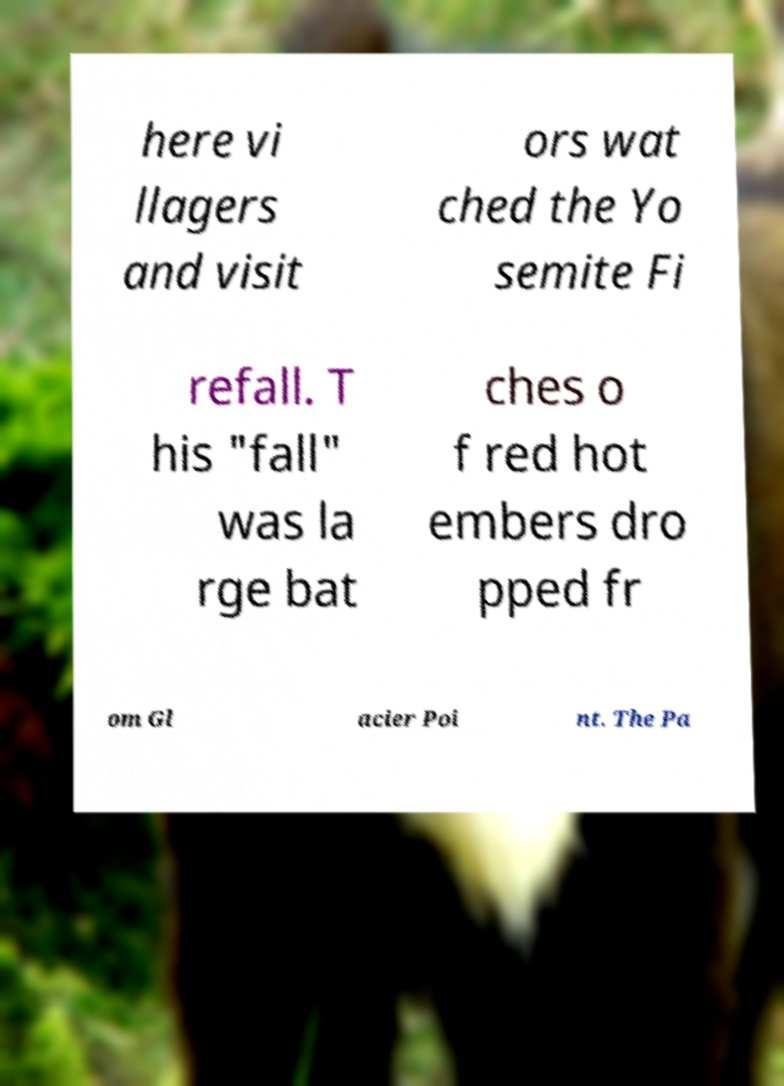Could you assist in decoding the text presented in this image and type it out clearly? here vi llagers and visit ors wat ched the Yo semite Fi refall. T his "fall" was la rge bat ches o f red hot embers dro pped fr om Gl acier Poi nt. The Pa 